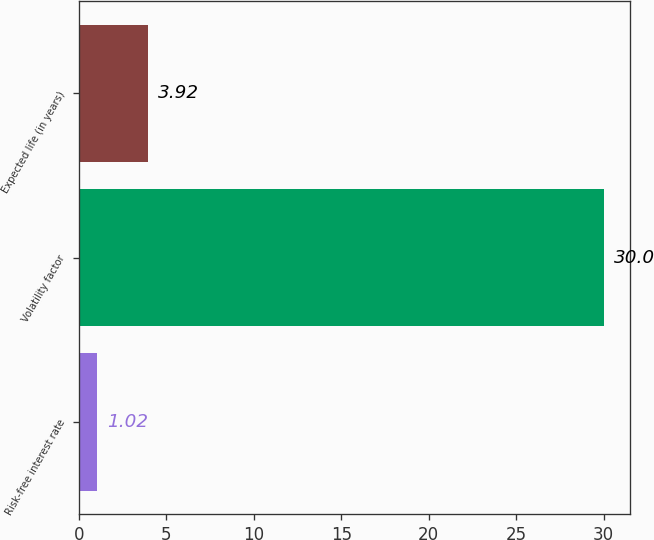<chart> <loc_0><loc_0><loc_500><loc_500><bar_chart><fcel>Risk-free interest rate<fcel>Volatility factor<fcel>Expected life (in years)<nl><fcel>1.02<fcel>30<fcel>3.92<nl></chart> 